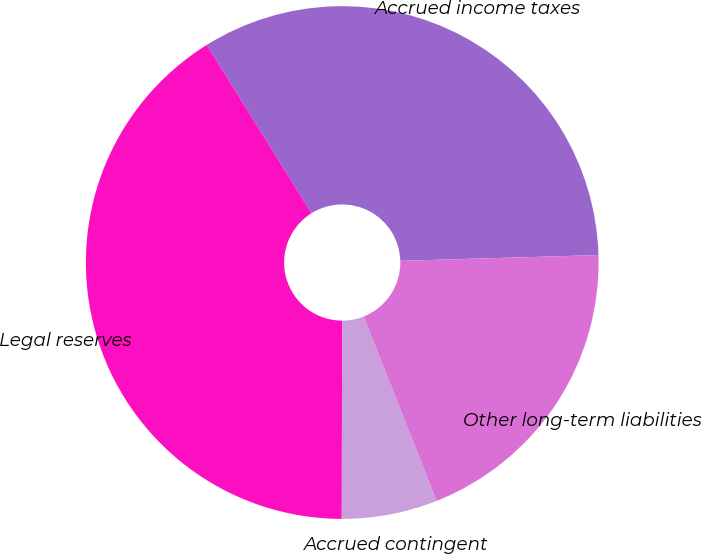Convert chart to OTSL. <chart><loc_0><loc_0><loc_500><loc_500><pie_chart><fcel>Accrued income taxes<fcel>Legal reserves<fcel>Accrued contingent<fcel>Other long-term liabilities<nl><fcel>33.4%<fcel>41.1%<fcel>6.03%<fcel>19.46%<nl></chart> 